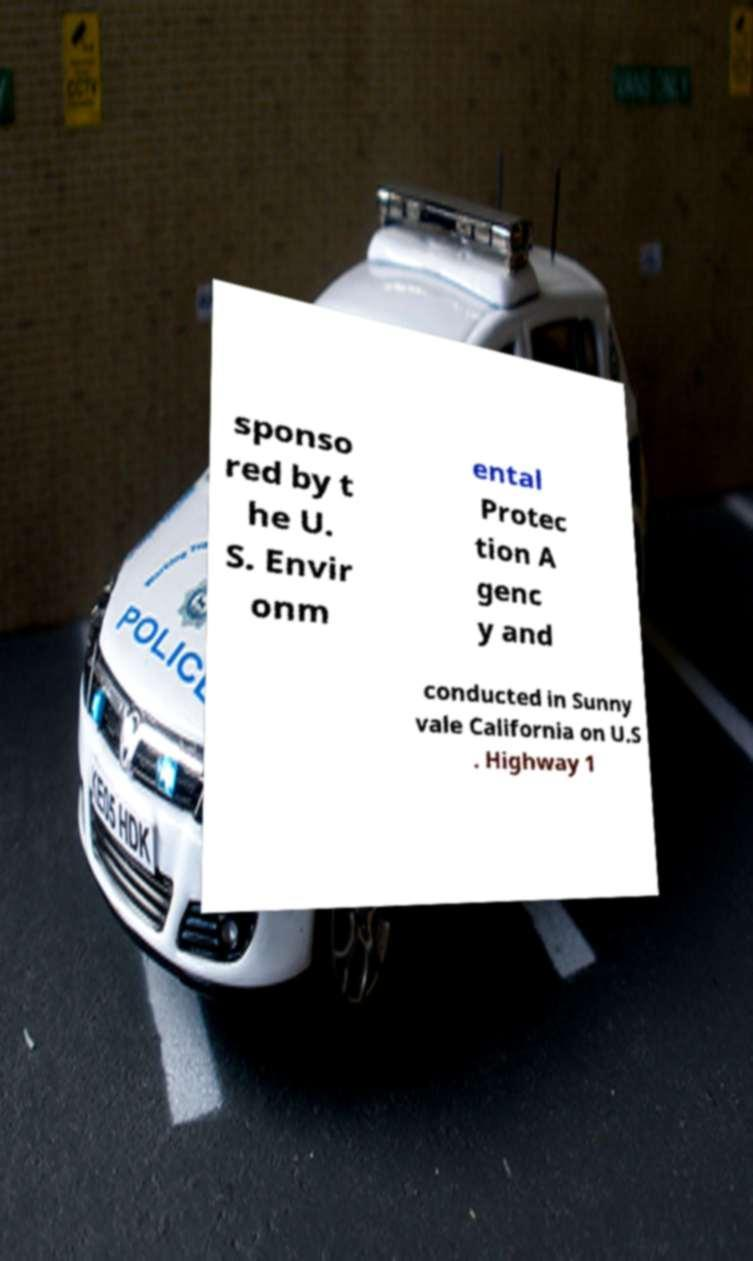There's text embedded in this image that I need extracted. Can you transcribe it verbatim? sponso red by t he U. S. Envir onm ental Protec tion A genc y and conducted in Sunny vale California on U.S . Highway 1 